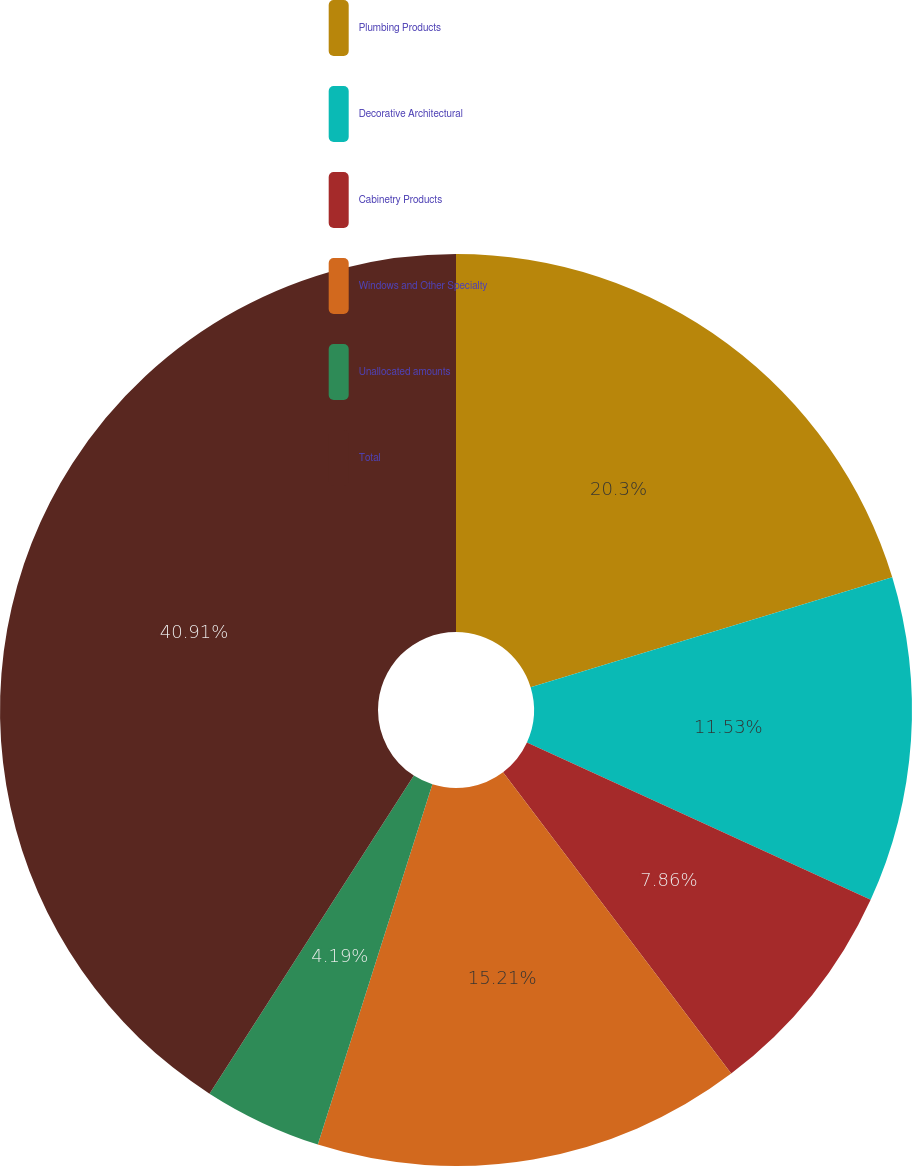<chart> <loc_0><loc_0><loc_500><loc_500><pie_chart><fcel>Plumbing Products<fcel>Decorative Architectural<fcel>Cabinetry Products<fcel>Windows and Other Specialty<fcel>Unallocated amounts<fcel>Total<nl><fcel>20.3%<fcel>11.53%<fcel>7.86%<fcel>15.21%<fcel>4.19%<fcel>40.91%<nl></chart> 